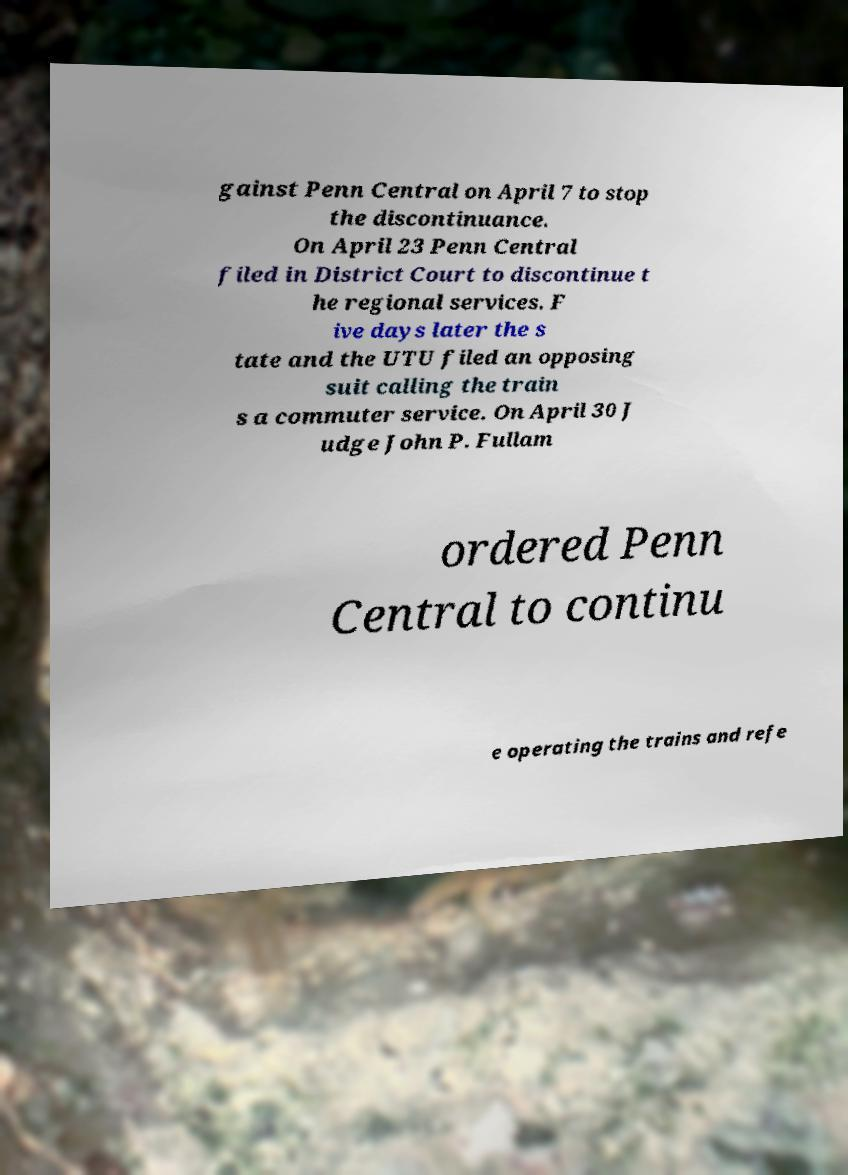For documentation purposes, I need the text within this image transcribed. Could you provide that? gainst Penn Central on April 7 to stop the discontinuance. On April 23 Penn Central filed in District Court to discontinue t he regional services. F ive days later the s tate and the UTU filed an opposing suit calling the train s a commuter service. On April 30 J udge John P. Fullam ordered Penn Central to continu e operating the trains and refe 